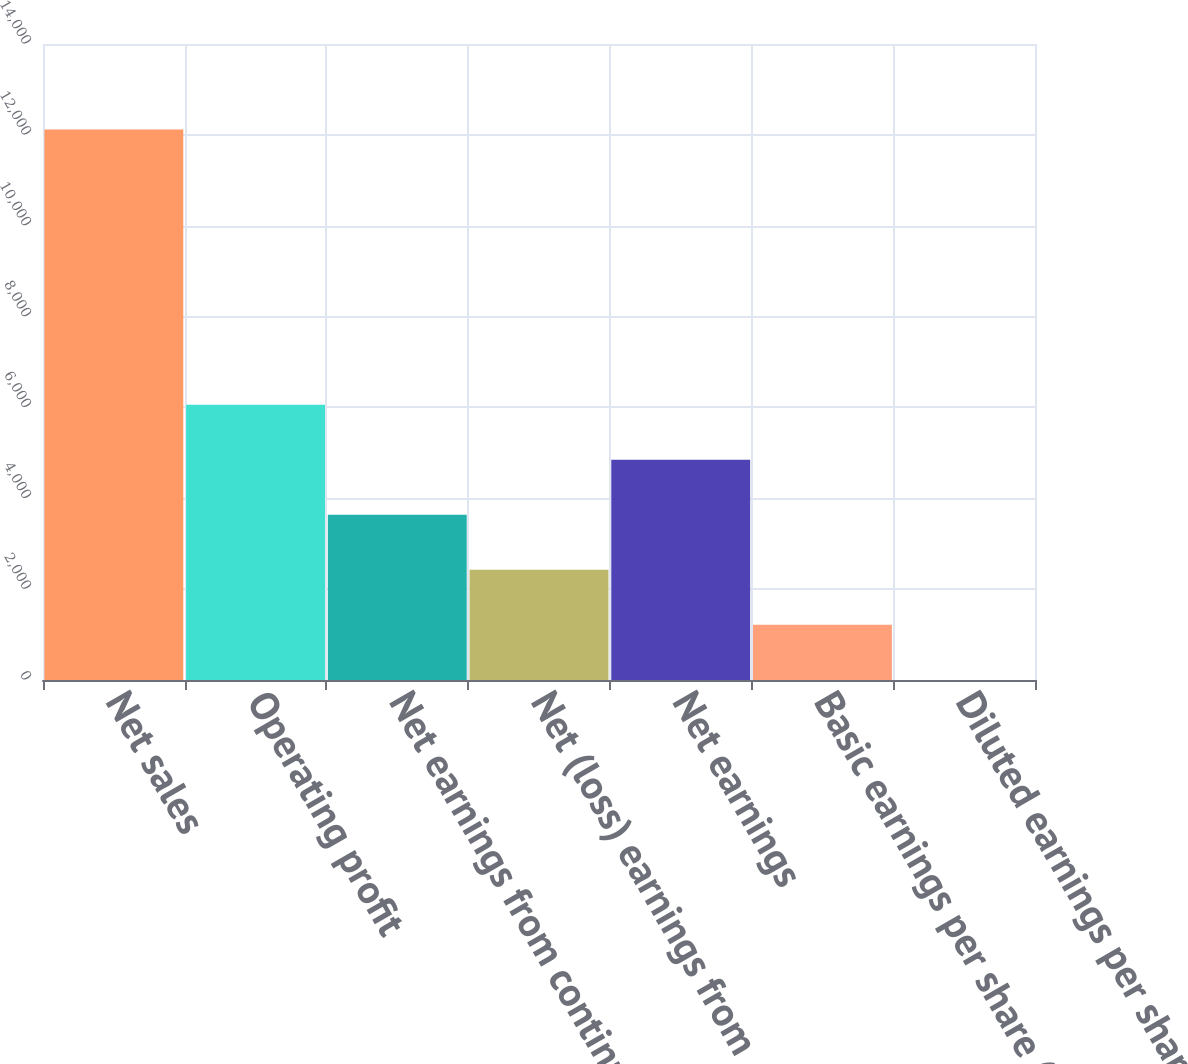<chart> <loc_0><loc_0><loc_500><loc_500><bar_chart><fcel>Net sales<fcel>Operating profit<fcel>Net earnings from continuing<fcel>Net (loss) earnings from<fcel>Net earnings<fcel>Basic earnings per share (c)<fcel>Diluted earnings per share (c)<nl><fcel>12119<fcel>6060.55<fcel>3637.17<fcel>2425.48<fcel>4848.86<fcel>1213.79<fcel>2.1<nl></chart> 